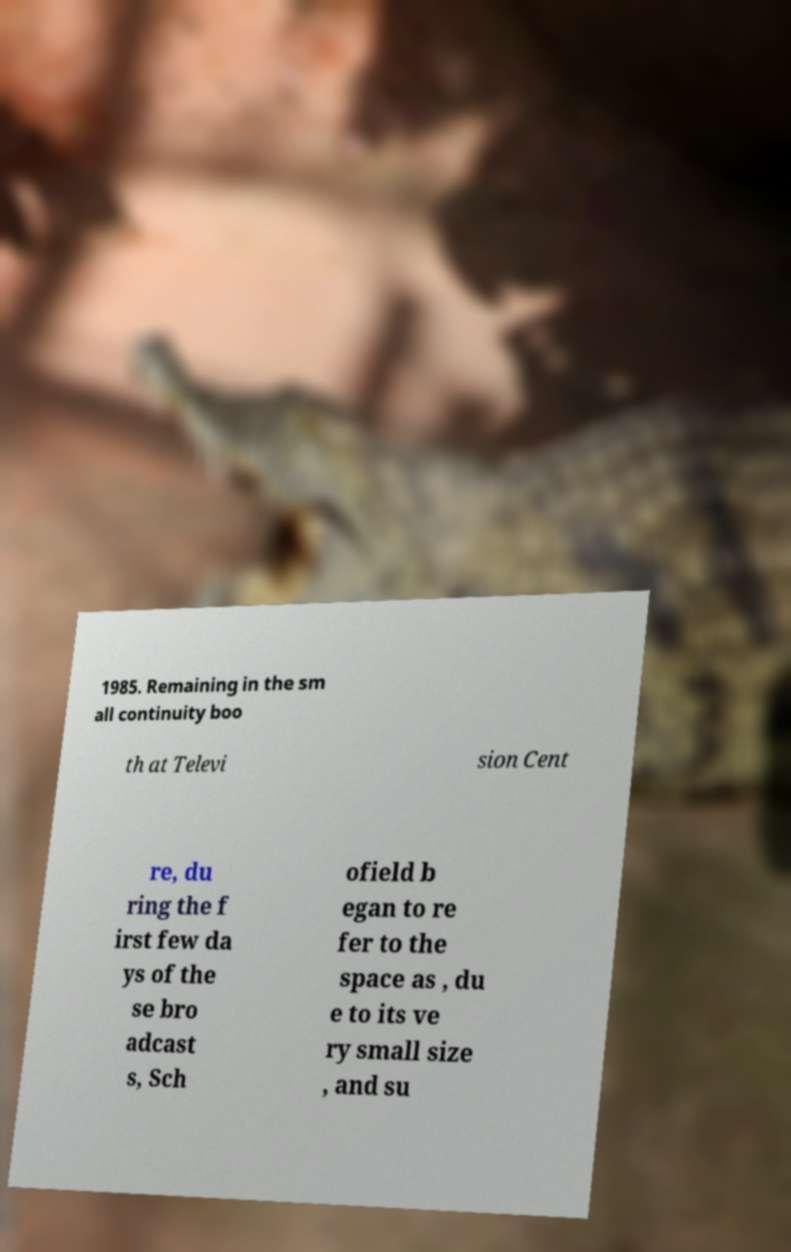What messages or text are displayed in this image? I need them in a readable, typed format. 1985. Remaining in the sm all continuity boo th at Televi sion Cent re, du ring the f irst few da ys of the se bro adcast s, Sch ofield b egan to re fer to the space as , du e to its ve ry small size , and su 